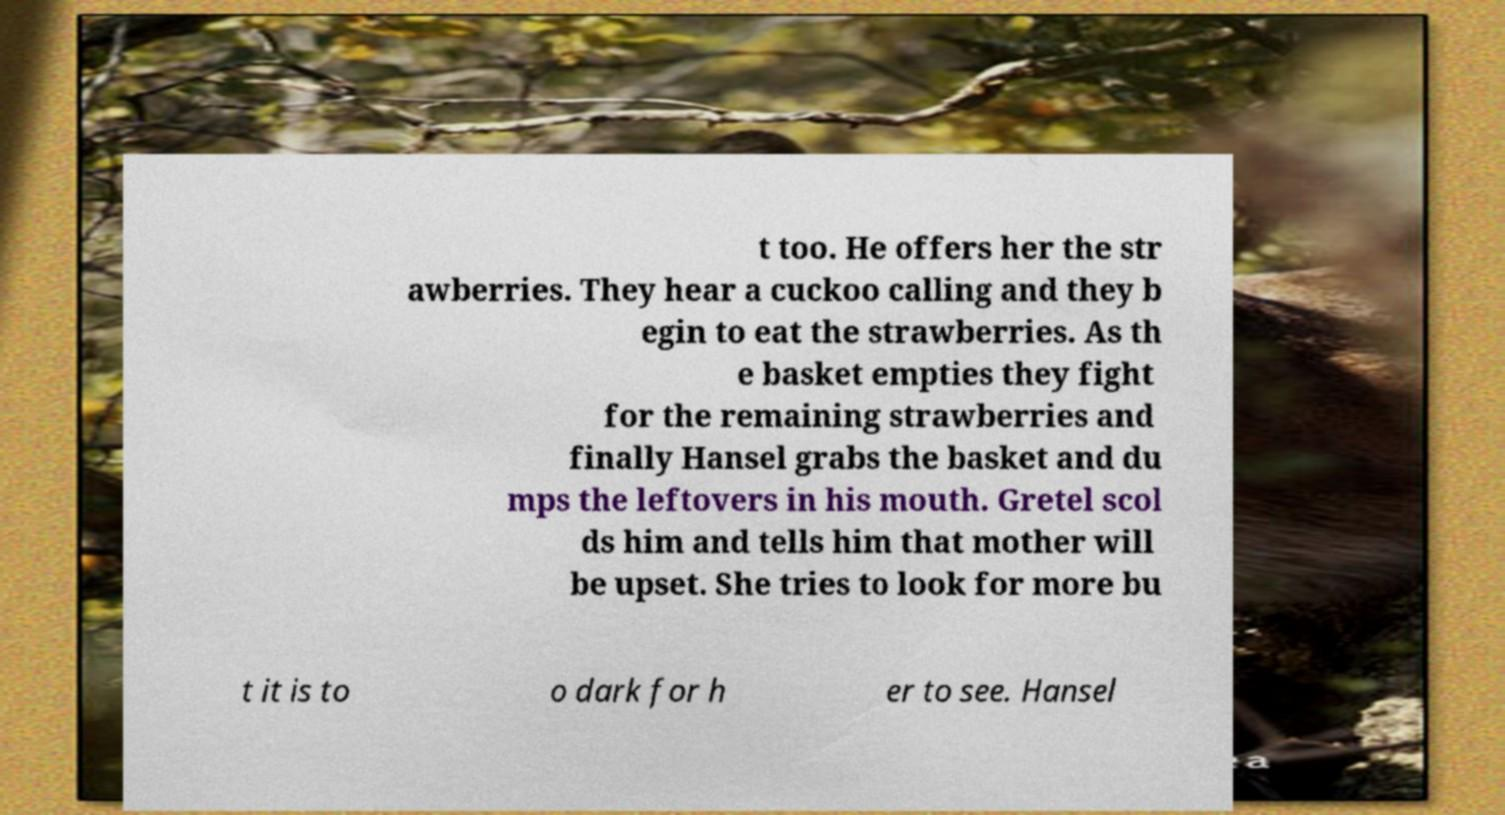I need the written content from this picture converted into text. Can you do that? t too. He offers her the str awberries. They hear a cuckoo calling and they b egin to eat the strawberries. As th e basket empties they fight for the remaining strawberries and finally Hansel grabs the basket and du mps the leftovers in his mouth. Gretel scol ds him and tells him that mother will be upset. She tries to look for more bu t it is to o dark for h er to see. Hansel 